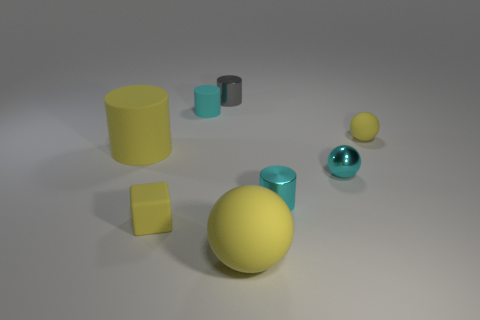Add 1 yellow spheres. How many objects exist? 9 Subtract all cubes. How many objects are left? 7 Subtract 0 green cylinders. How many objects are left? 8 Subtract all yellow rubber objects. Subtract all tiny yellow rubber things. How many objects are left? 2 Add 4 cyan things. How many cyan things are left? 7 Add 7 cyan objects. How many cyan objects exist? 10 